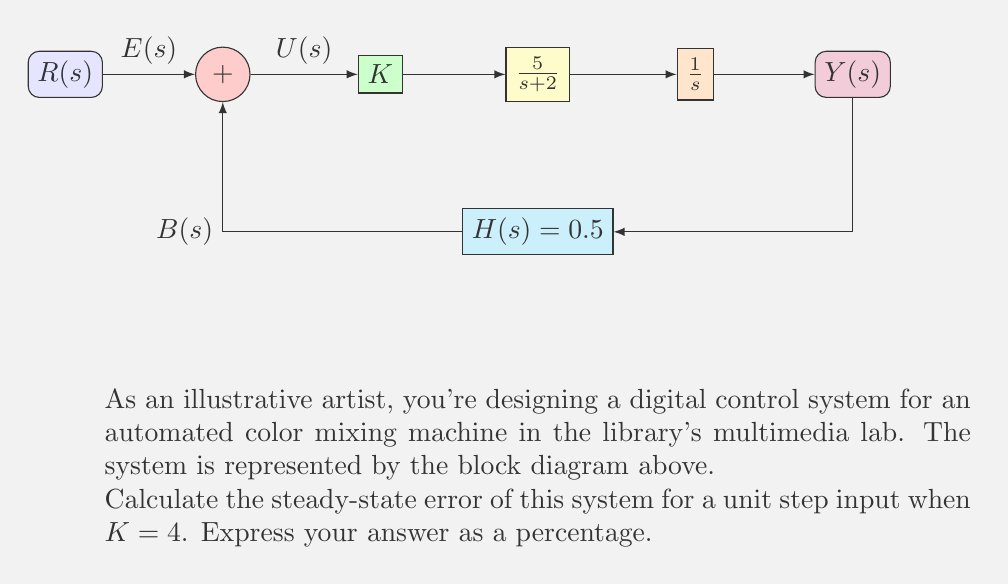Can you answer this question? Let's approach this step-by-step:

1) First, we need to find the open-loop transfer function $G(s)H(s)$:

   $$G(s)H(s) = K \cdot \frac{5}{s+2} \cdot \frac{1}{s} \cdot 0.5 = \frac{2.5K}{s(s+2)}$$

2) For a unit step input, the steady-state error is given by:

   $$e_{ss} = \frac{1}{1 + \lim_{s \to 0} sG(s)H(s)}$$

3) Let's calculate $\lim_{s \to 0} sG(s)H(s)$:

   $$\lim_{s \to 0} sG(s)H(s) = \lim_{s \to 0} s \cdot \frac{2.5K}{s(s+2)} = \lim_{s \to 0} \frac{2.5K}{s+2} = 1.25K$$

4) Now we can substitute this into our steady-state error equation:

   $$e_{ss} = \frac{1}{1 + 1.25K}$$

5) Given that $K = 4$, let's calculate the error:

   $$e_{ss} = \frac{1}{1 + 1.25(4)} = \frac{1}{6} = 0.1666...$$

6) To express this as a percentage, we multiply by 100:

   $$e_{ss} (\%) = 0.1666... \times 100 = 16.67\%$$
Answer: 16.67% 